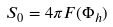<formula> <loc_0><loc_0><loc_500><loc_500>S _ { 0 } = 4 \pi F ( \Phi _ { h } )</formula> 